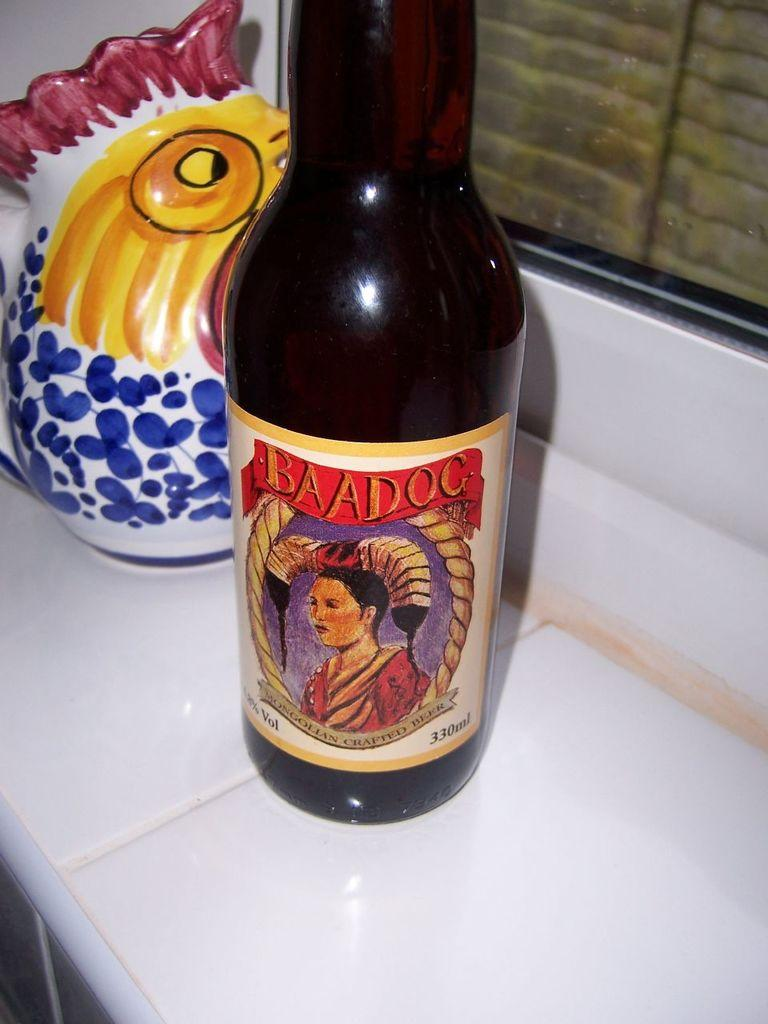Provide a one-sentence caption for the provided image. Bottle of BAADOC bear on a windowsill by a ceramic chicken. 